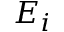<formula> <loc_0><loc_0><loc_500><loc_500>E _ { i }</formula> 